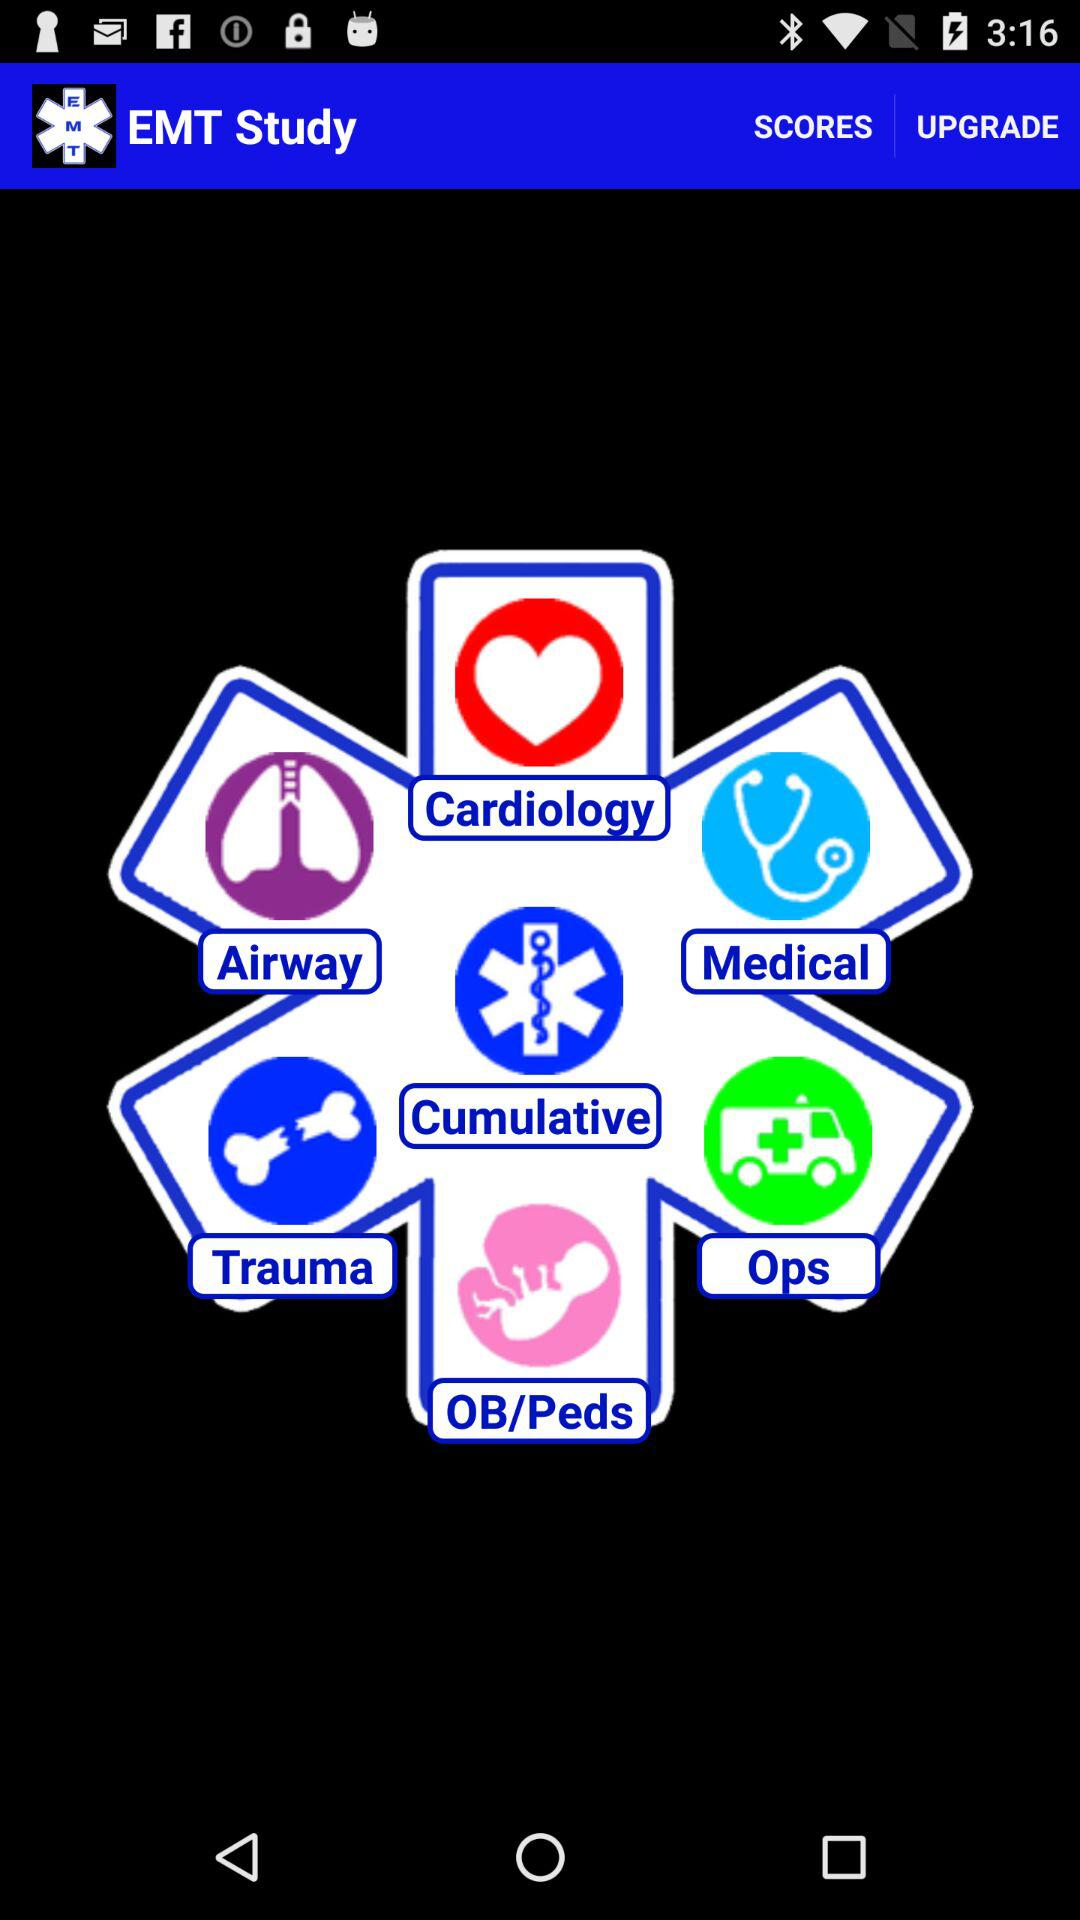What is the name of the application? The name of the application is "EMT Study". 